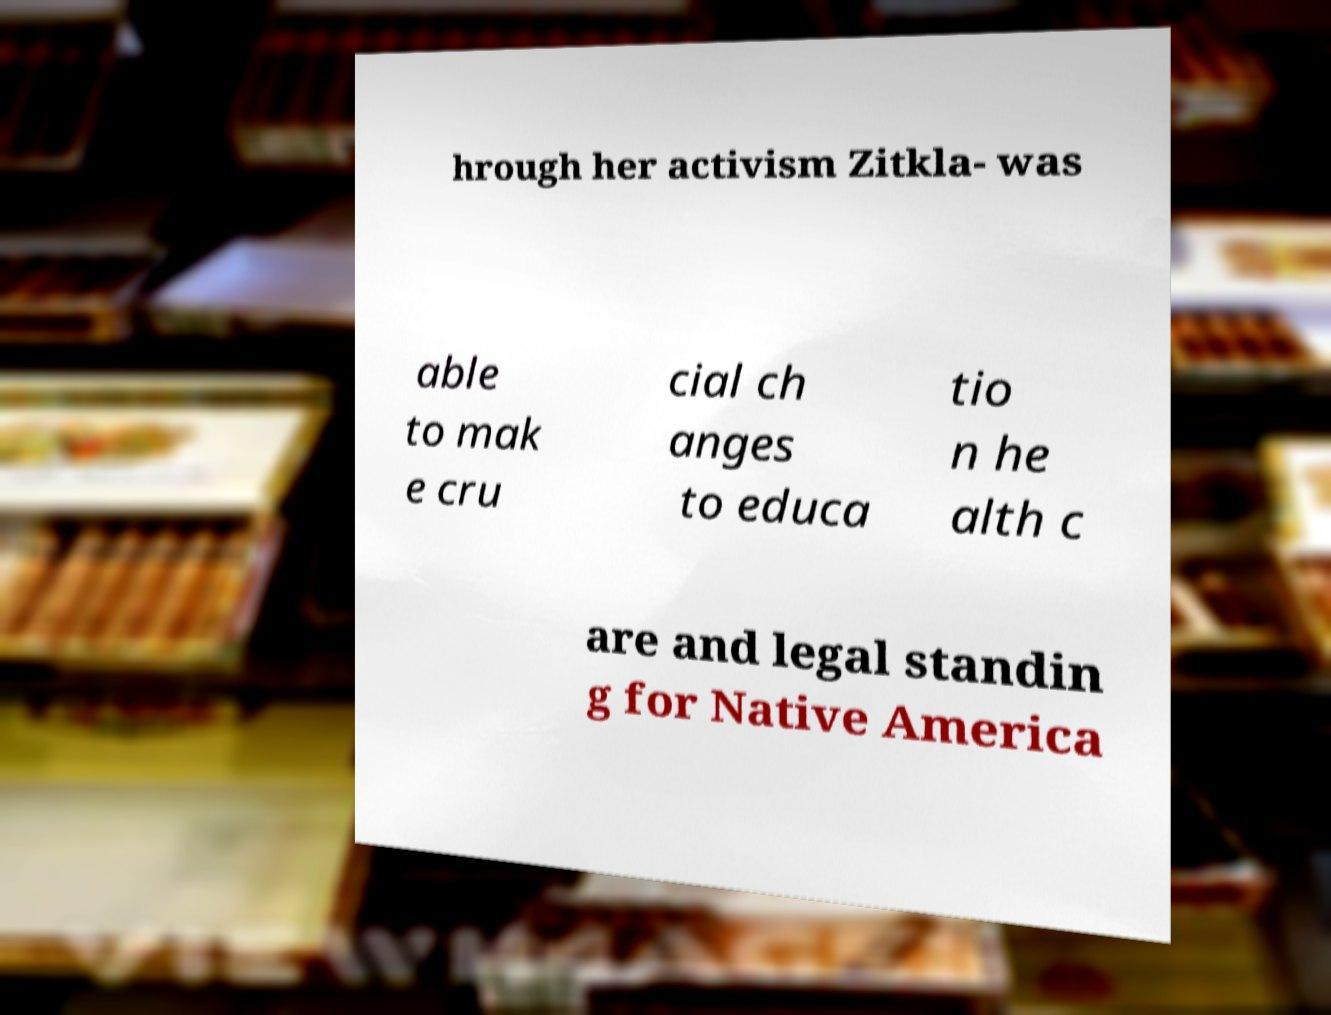There's text embedded in this image that I need extracted. Can you transcribe it verbatim? hrough her activism Zitkla- was able to mak e cru cial ch anges to educa tio n he alth c are and legal standin g for Native America 